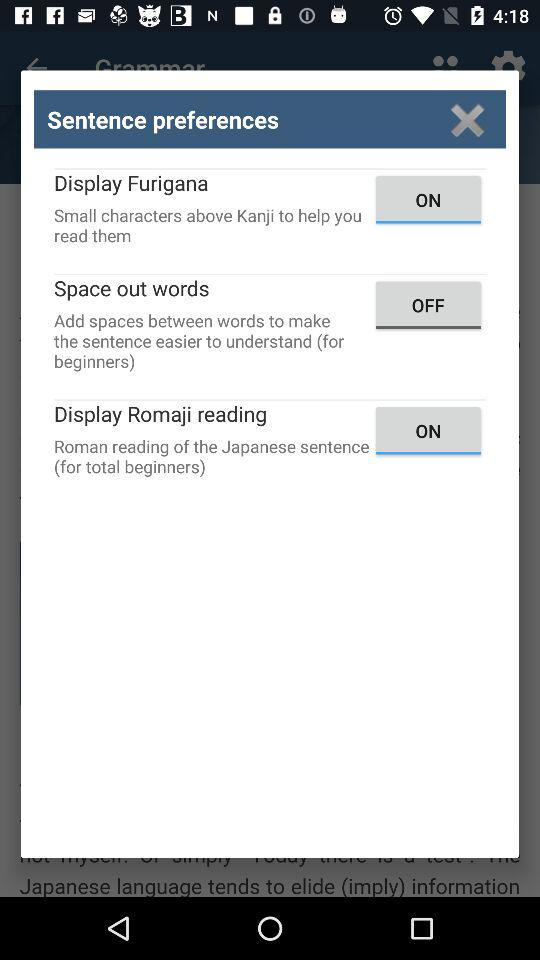What is the status of "Space out words"? The status of "Space out words" is "off". 